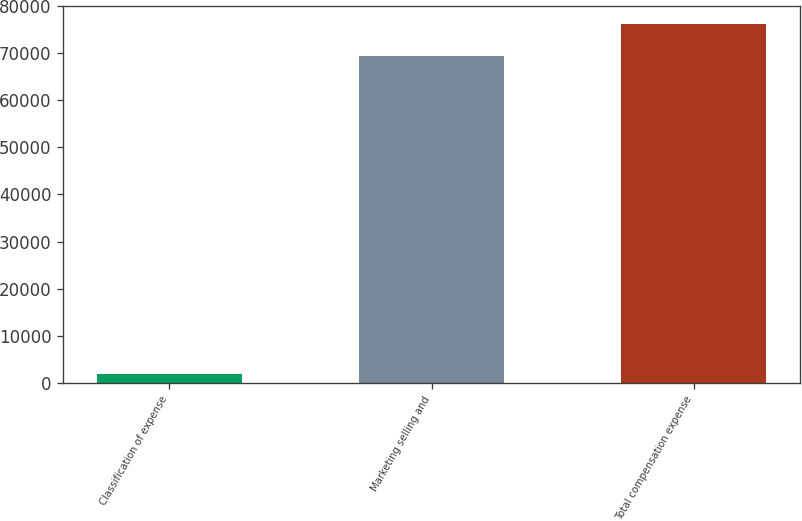Convert chart. <chart><loc_0><loc_0><loc_500><loc_500><bar_chart><fcel>Classification of expense<fcel>Marketing selling and<fcel>Total compensation expense<nl><fcel>2017<fcel>69459<fcel>76203.2<nl></chart> 